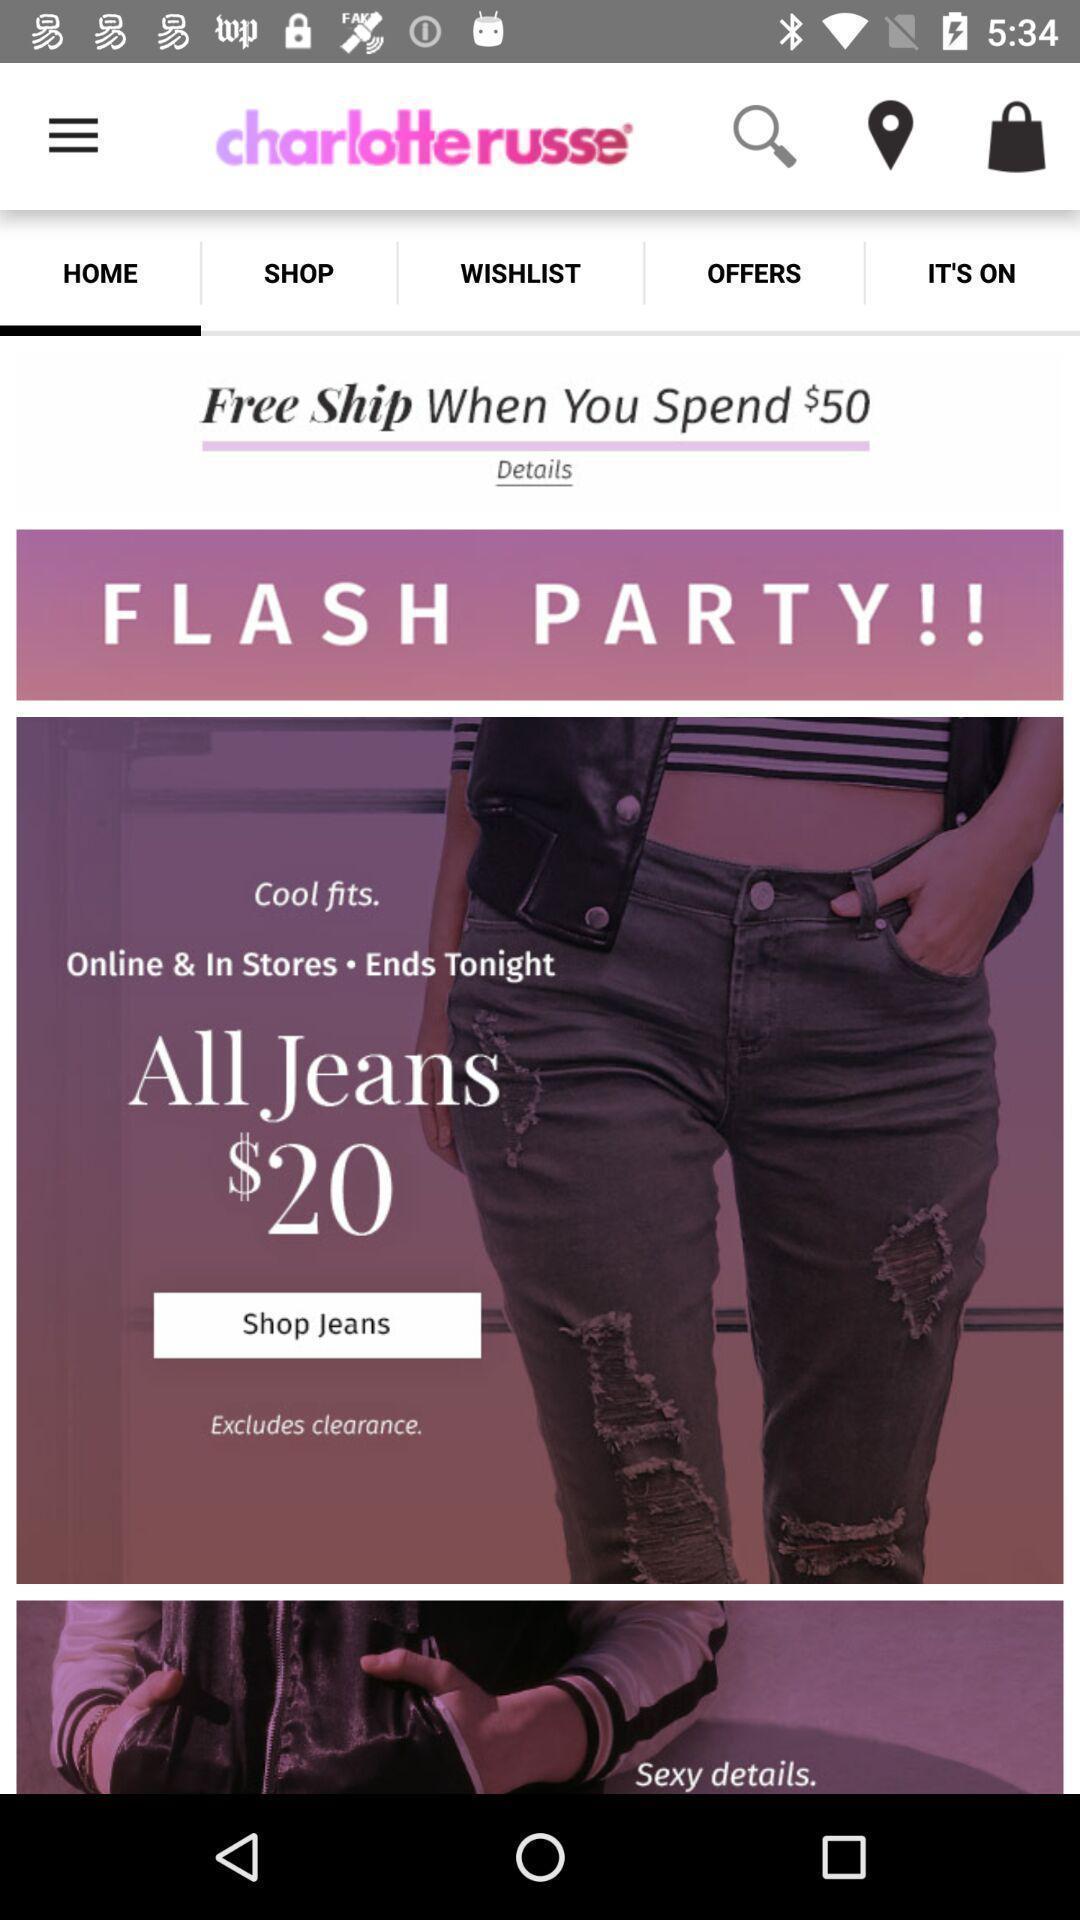Provide a detailed account of this screenshot. Home page of a shopping app. 